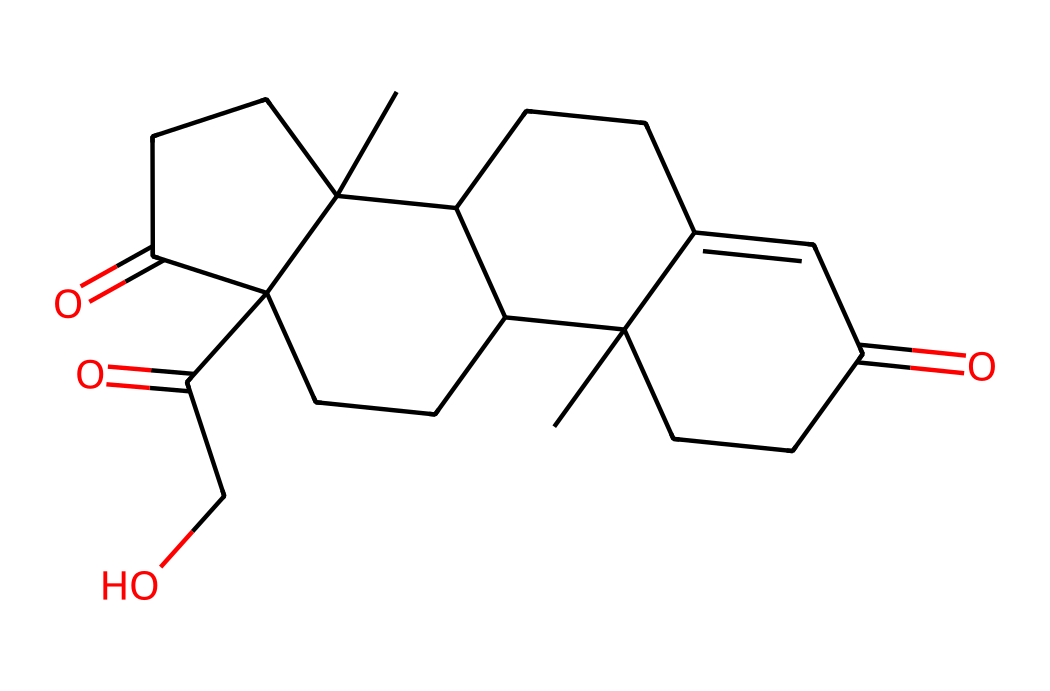What is the molecular formula of cortisol? To find the molecular formula, count the number of each type of atom in the SMILES representation provided. The formula can be derived as C21H30O5 by identifying the number of carbon (C), hydrogen (H), and oxygen (O) atoms present.
Answer: C21H30O5 How many carbon atoms are in cortisol? By analyzing the SMILES notation, count the number of carbon atoms represented in the structure, resulting in a total count of 21.
Answer: 21 What type of chemical is cortisol classified as? Cortisol is a steroid hormone, which can be identified through its distinct four-ring core structure typical of steroid hormones.
Answer: steroid What is the primary functional group present in cortisol? The SMILES indicates that cortisol has ketone groups due to the presence of carbonyl (C=O) functionalities, which can be identified by examining the structure for double-bonded oxygen atoms connected to carbon.
Answer: ketone How many oxygen atoms are in the cortisol molecule? Counting the number of oxygen atoms by examining the SMILES representation reveals there are 5 oxygen atoms present in the chemical structure.
Answer: 5 What characteristic of cortisol relates to its role as a stress hormone? The presence of specific functional groups and molecular configuration in cortisol, particularly the carbonyl and hydroxyl groups, can influence its biological activity, as these features are critical for its interaction with receptors in the body.
Answer: functional groups What is the significance of the fused ring structure in cortisol's function? The fused ring structure of cortisol contributes to its stability and ability to interact with hormone receptors, making it an effective messenger in the body's stress response.
Answer: stability and receptor interaction 